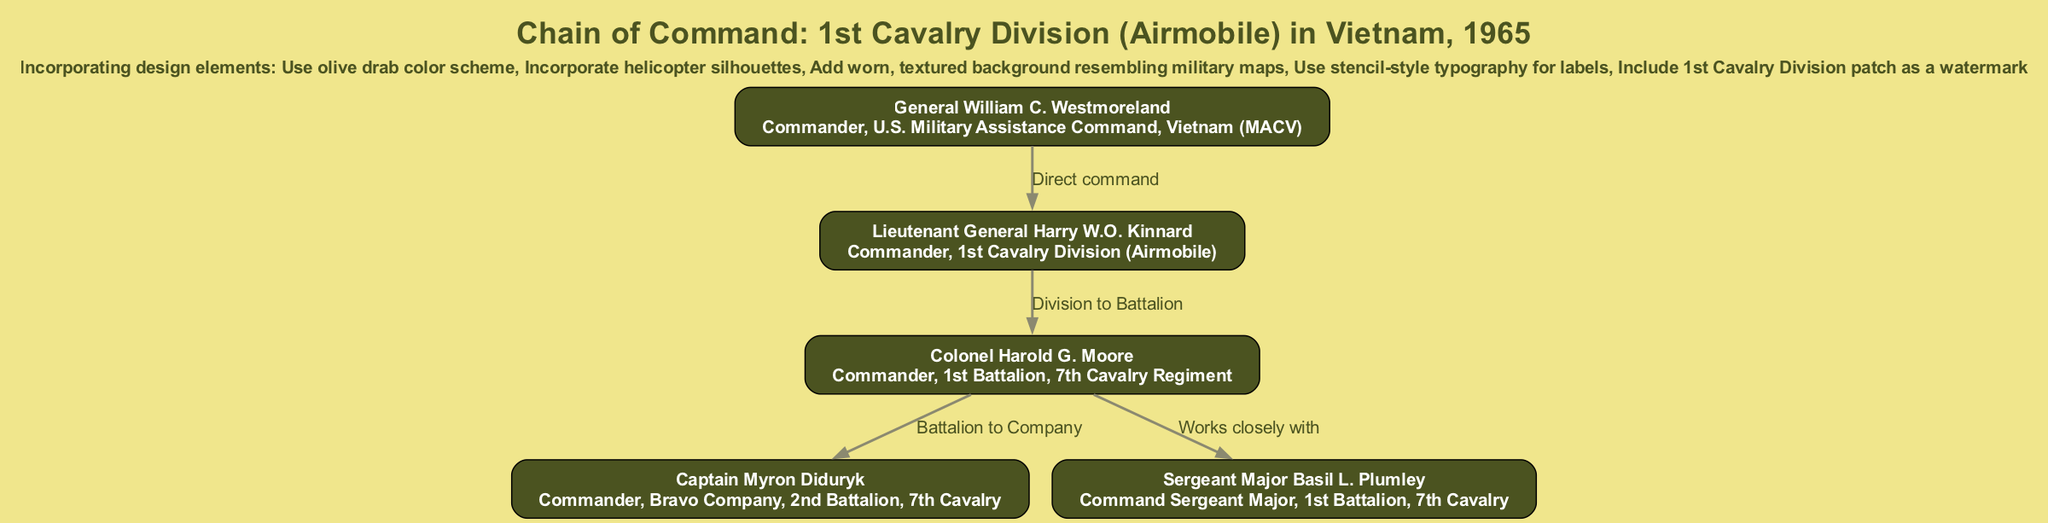What is the title of the diagram? The title of the diagram is prominently displayed at the top and reflects the content about the military unit during the Vietnam War.
Answer: Chain of Command: 1st Cavalry Division (Airmobile) in Vietnam, 1965 How many nodes are present in the diagram? By counting the individual entities represented in the diagram, there are five nodes listed that depict the members of the command chain.
Answer: 5 Who reports directly to General William C. Westmoreland? The edge labeled 'Direct command' connects General William C. Westmoreland to Lieutenant General Harry W.O. Kinnard, indicating that Kinnard is his direct report.
Answer: Lieutenant General Harry W.O. Kinnard What is the role of Colonel Harold G. Moore? The diagram specifies the role associated with Colonel Harold G. Moore directly under his name within the node.
Answer: Commander, 1st Battalion, 7th Cavalry Regiment Which two ranks are closely associated within the chain of command? The connection labeled 'Works closely with' between Colonel Harold G. Moore and Sergeant Major Basil L. Plumley identifies their close working relationship.
Answer: Colonel Harold G. Moore and Sergeant Major Basil L. Plumley What design element reflects the military theme in the diagram? The diagram incorporates several design elements, one of which is the textured background resembling military maps, emphasizing its military context.
Answer: Worn, textured background resembling military maps Which rank commands the Bravo Company? The node for Captain Myron Diduryk explicitly states his command over Bravo Company, making it clear who holds that position.
Answer: Captain Myron Diduryk How does the design of the diagram reflect the era of the Vietnam War? The olive drab color scheme and stencil-style typography are specific design choices that evoke the military aesthetic typical of the Vietnam War period, connecting visually with that historical context.
Answer: Olive drab color scheme and stencil-style typography What type of diagram is presented? The diagram presents a hierarchical structure that clearly outlines the chain of command within a military unit, indicating relationships of authority.
Answer: Hierarchical diagram 